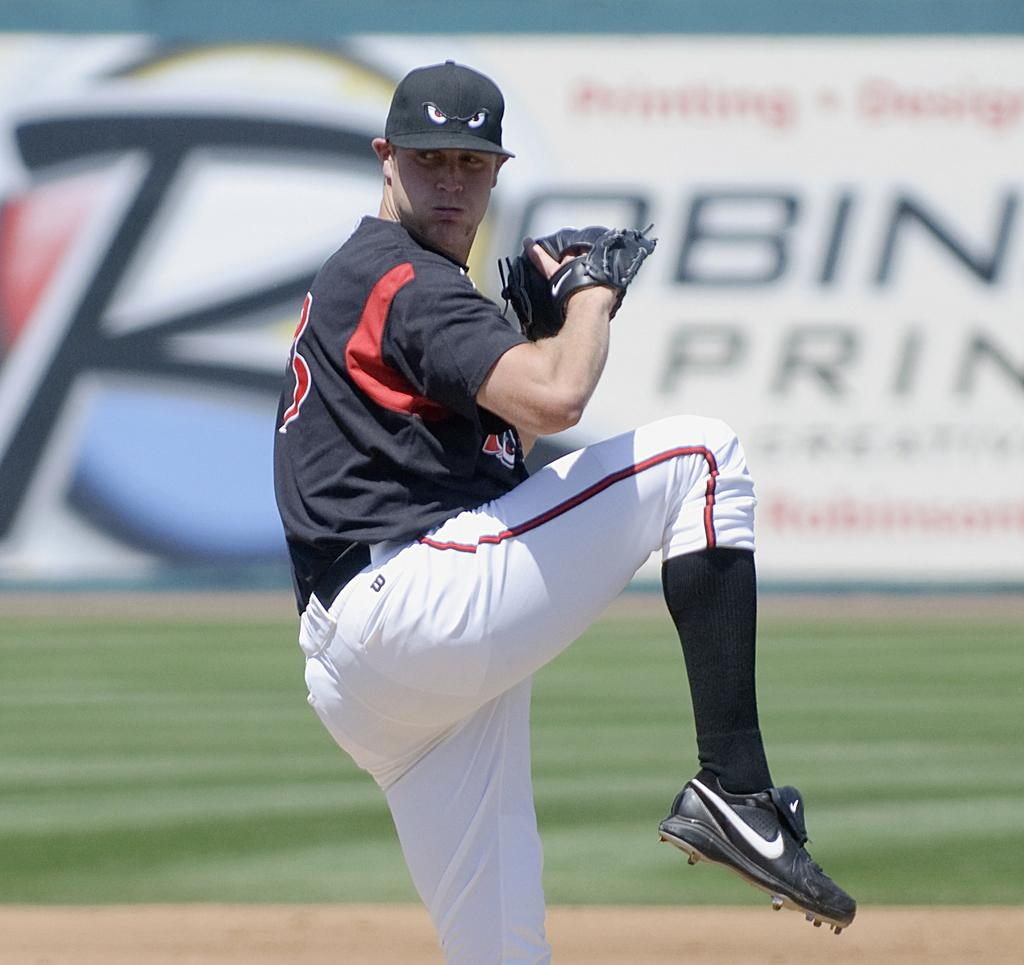<image>
Describe the image concisely. The pitcher has a small black W on his pants near the waistband. 